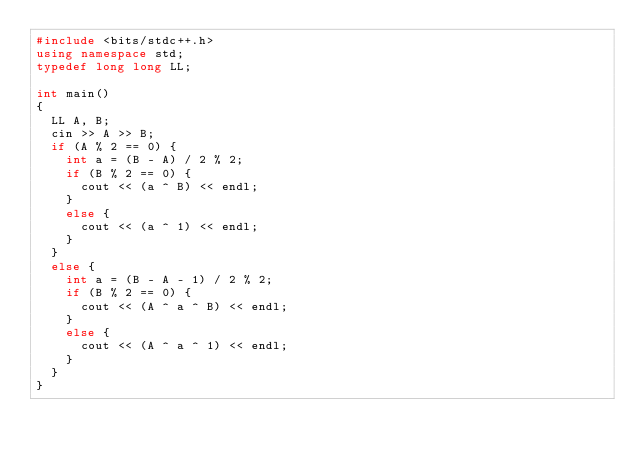<code> <loc_0><loc_0><loc_500><loc_500><_C++_>#include <bits/stdc++.h>
using namespace std;
typedef long long LL;

int main()
{
	LL A, B;
	cin >> A >> B;
	if (A % 2 == 0) {
		int a = (B - A) / 2 % 2;
		if (B % 2 == 0) {
			cout << (a ^ B) << endl;
		}
		else {
			cout << (a ^ 1) << endl;
		}
	}
	else {
		int a = (B - A - 1) / 2 % 2;
		if (B % 2 == 0) {
			cout << (A ^ a ^ B) << endl;
		}
		else {
			cout << (A ^ a ^ 1) << endl;
		}
	}
}

</code> 